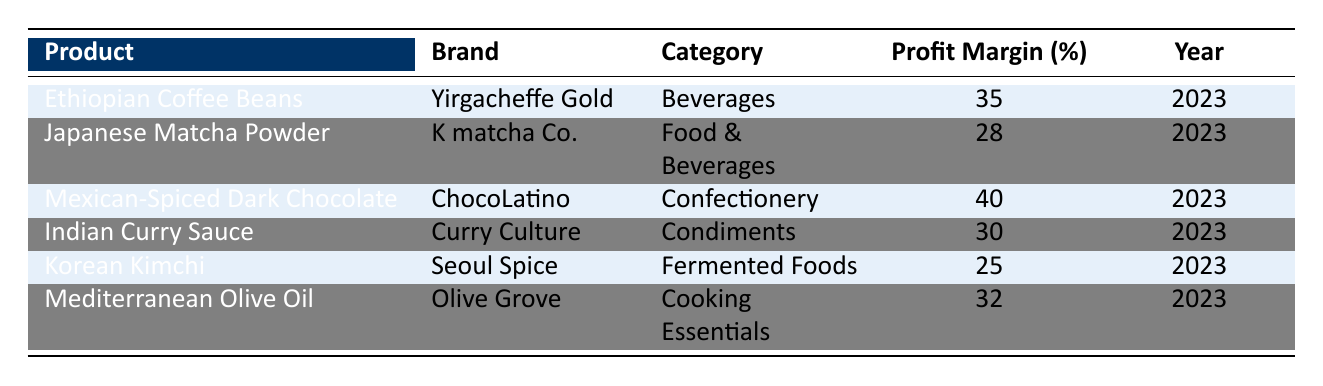What is the profit margin for Mexican-Spiced Dark Chocolate? The table lists the product "Mexican-Spiced Dark Chocolate" with a profit margin percentage of 40 in 2023.
Answer: 40 Which product has the lowest profit margin? By reviewing the profit margin percentages in the table, "Korean Kimchi" has the lowest at 25%.
Answer: 25 What is the average profit margin of all the products listed? To calculate the average profit margin, sum the profit margins: 35 + 28 + 40 + 30 + 25 + 32 = 190. There are 6 products, so the average is 190/6 = 31.67.
Answer: 31.67 Does Indian Curry Sauce have a higher profit margin than Japanese Matcha Powder? The profit margin for Indian Curry Sauce is 30% and for Japanese Matcha Powder it is 28%. Since 30% is greater than 28%, the answer is yes.
Answer: Yes Which category has the highest profit margin and what is that margin? Look at the profit margins for each category: Beverages (35%), Food & Beverages (28%), Confectionery (40%), Condiments (30%), Fermented Foods (25%), and Cooking Essentials (32%). The highest is from Confectionery at 40%.
Answer: Confectionery, 40 What profit margin percentage do Mediterranean Olive Oil and Ethiopian Coffee Beans share? Mediterranean Olive Oil has a profit margin of 32% and Ethiopian Coffee Beans has 35%. They do not share the same profit margin percentage.
Answer: No What is the profit margin difference between Ethiopian Coffee Beans and Korean Kimchi? The profit margin for Ethiopian Coffee Beans is 35%, and for Korean Kimchi is 25%. The difference is 35 - 25 = 10%.
Answer: 10 Is there any product category that has a profit margin of 30% or greater? By reviewing the profit margins: Beverages (35%), Food & Beverages (28%), Confectionery (40%), Condiments (30%), Fermented Foods (25%), and Cooking Essentials (32%), the answer is yes, as we have several categories above 30%.
Answer: Yes How many products in the table are classified as condiments? The only product listed under condiments is "Indian Curry Sauce." Thus, there is only one product.
Answer: 1 